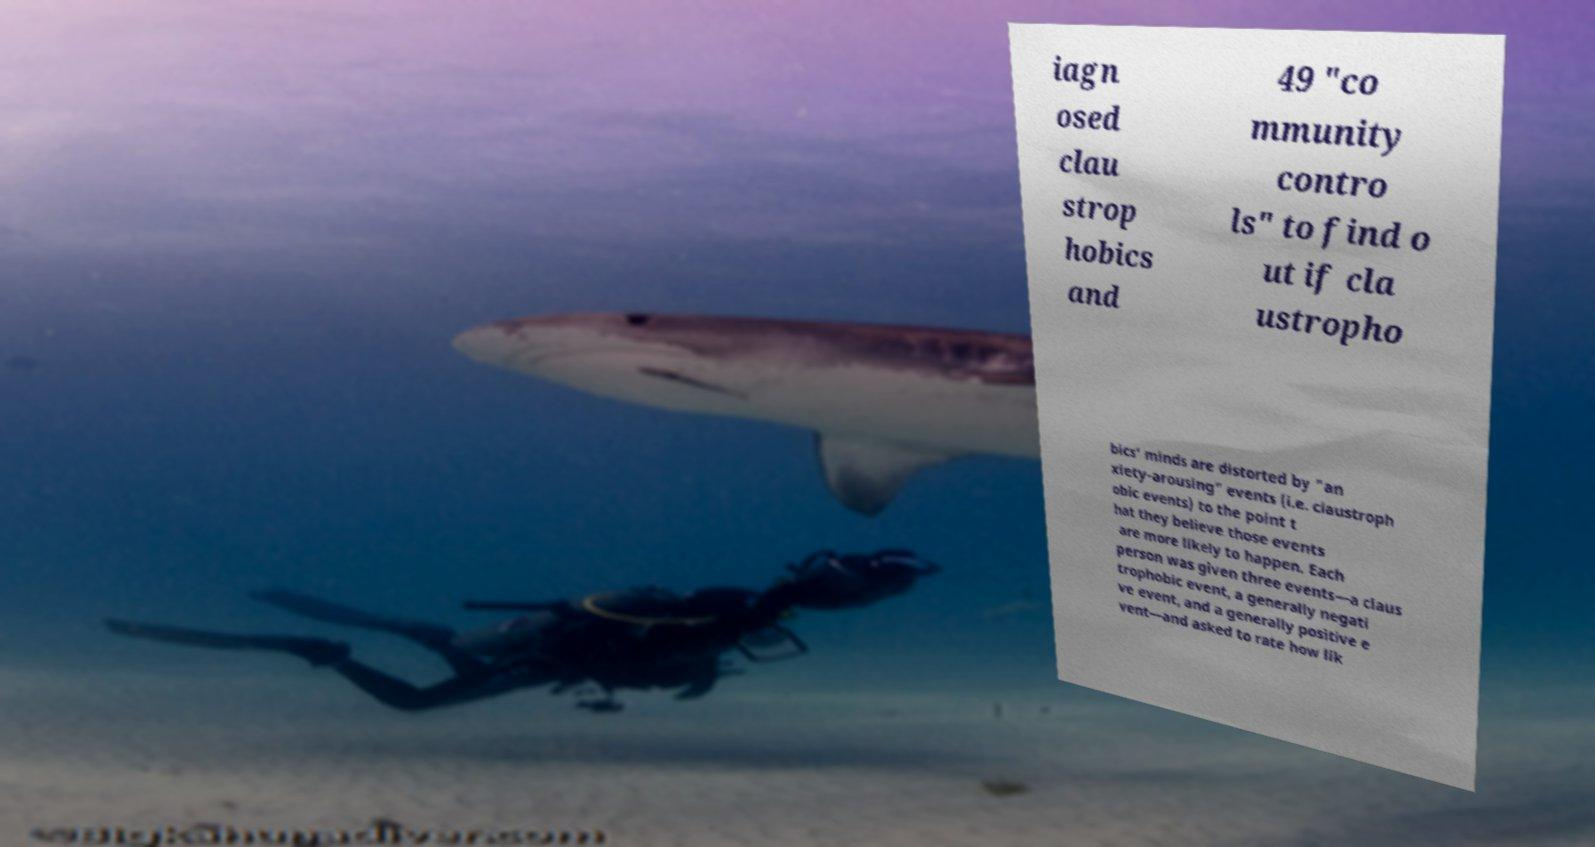Could you assist in decoding the text presented in this image and type it out clearly? iagn osed clau strop hobics and 49 "co mmunity contro ls" to find o ut if cla ustropho bics' minds are distorted by "an xiety-arousing" events (i.e. claustroph obic events) to the point t hat they believe those events are more likely to happen. Each person was given three events—a claus trophobic event, a generally negati ve event, and a generally positive e vent—and asked to rate how lik 